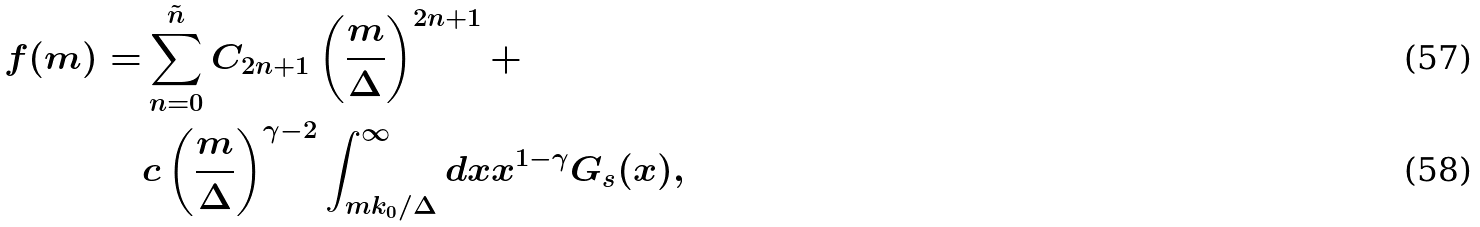Convert formula to latex. <formula><loc_0><loc_0><loc_500><loc_500>f ( m ) = & \sum _ { n = 0 } ^ { \tilde { n } } C _ { 2 n + 1 } \left ( \frac { m } { \Delta } \right ) ^ { 2 n + 1 } + \\ & c \left ( \frac { m } { \Delta } \right ) ^ { \gamma - 2 } \int _ { m k _ { 0 } / \Delta } ^ { \infty } d x x ^ { 1 - \gamma } G _ { s } ( x ) ,</formula> 